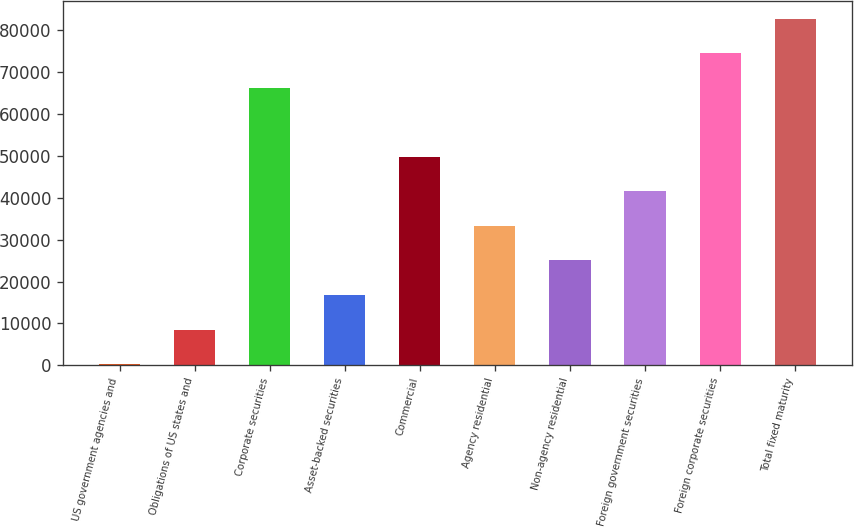Convert chart. <chart><loc_0><loc_0><loc_500><loc_500><bar_chart><fcel>US government agencies and<fcel>Obligations of US states and<fcel>Corporate securities<fcel>Asset-backed securities<fcel>Commercial<fcel>Agency residential<fcel>Non-agency residential<fcel>Foreign government securities<fcel>Foreign corporate securities<fcel>Total fixed maturity<nl><fcel>287<fcel>8532<fcel>66247<fcel>16777<fcel>49757<fcel>33267<fcel>25022<fcel>41512<fcel>74492<fcel>82737<nl></chart> 